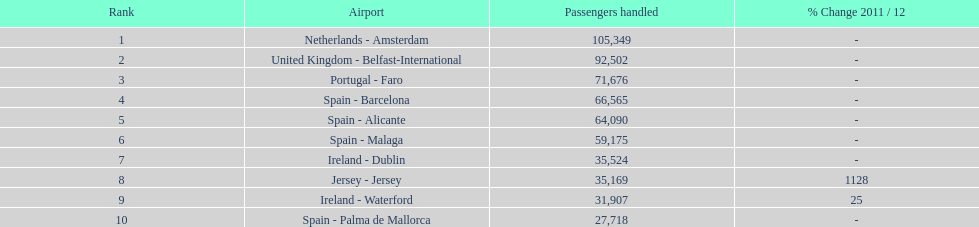What is the count of listed airports? 10. 